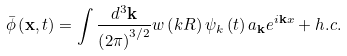Convert formula to latex. <formula><loc_0><loc_0><loc_500><loc_500>\bar { \phi } \left ( { \mathbf x } , t \right ) = \int \frac { d ^ { 3 } { \mathbf k } } { \left ( 2 \pi \right ) ^ { 3 / 2 } } w \left ( k R \right ) \psi _ { k } \left ( t \right ) a _ { \mathbf k } e ^ { i { \mathbf k x } } + h . c .</formula> 